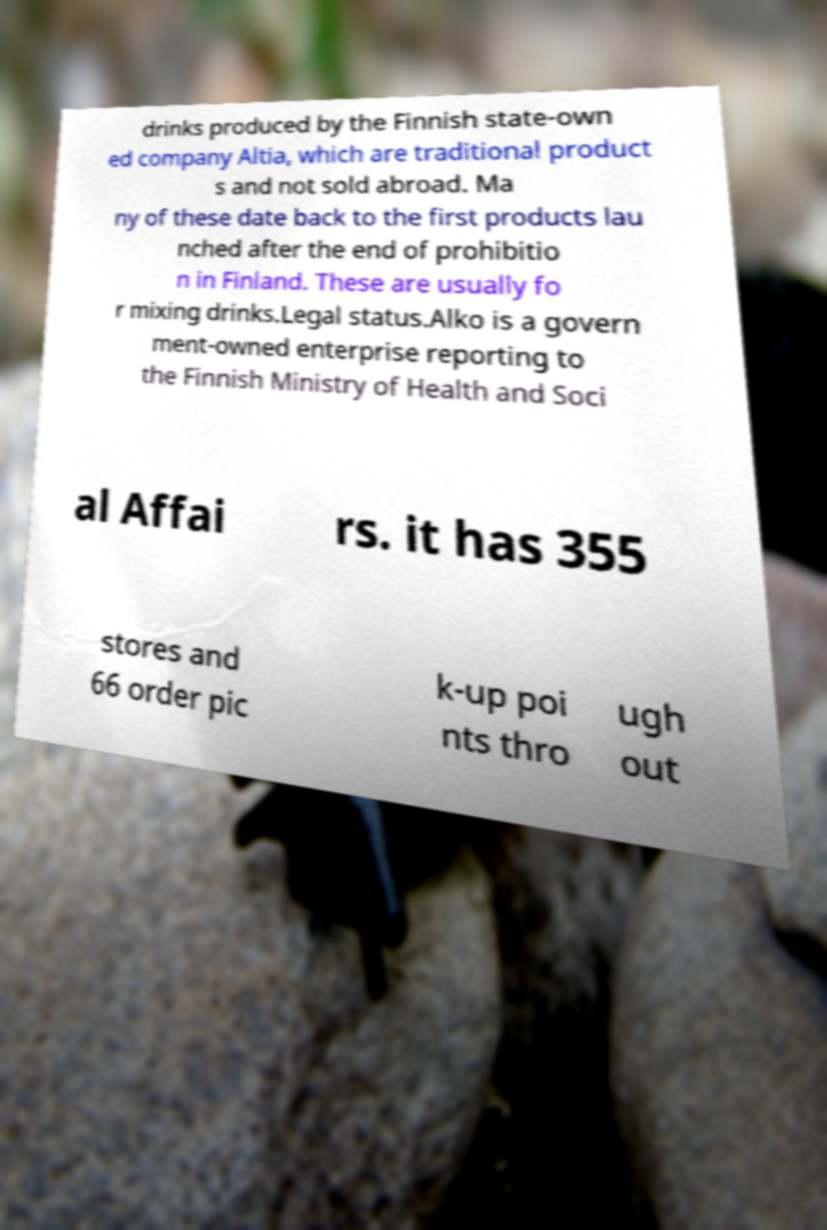What messages or text are displayed in this image? I need them in a readable, typed format. drinks produced by the Finnish state-own ed company Altia, which are traditional product s and not sold abroad. Ma ny of these date back to the first products lau nched after the end of prohibitio n in Finland. These are usually fo r mixing drinks.Legal status.Alko is a govern ment-owned enterprise reporting to the Finnish Ministry of Health and Soci al Affai rs. it has 355 stores and 66 order pic k-up poi nts thro ugh out 